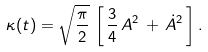<formula> <loc_0><loc_0><loc_500><loc_500>\kappa ( t ) = \sqrt { { \frac { \pi } { 2 } } } \, \left [ \, { \frac { 3 } { 4 } } \, A ^ { 2 } \, + \, \dot { A } ^ { 2 } \, \right ] .</formula> 